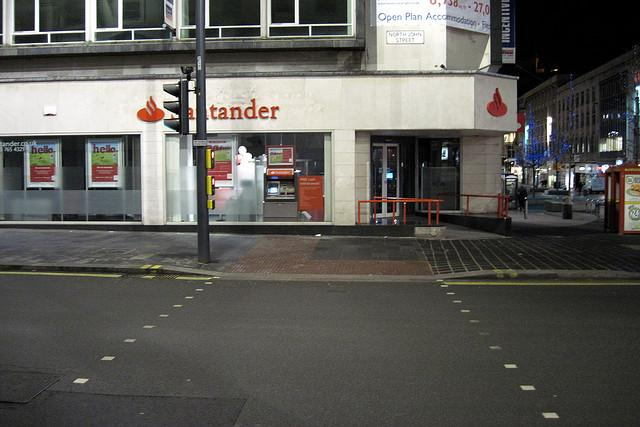What might come from the right or left at any time?

Choices:
A) lava
B) train
C) tank
D) car car 